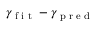Convert formula to latex. <formula><loc_0><loc_0><loc_500><loc_500>\gamma _ { f i t } - \gamma _ { p r e d }</formula> 